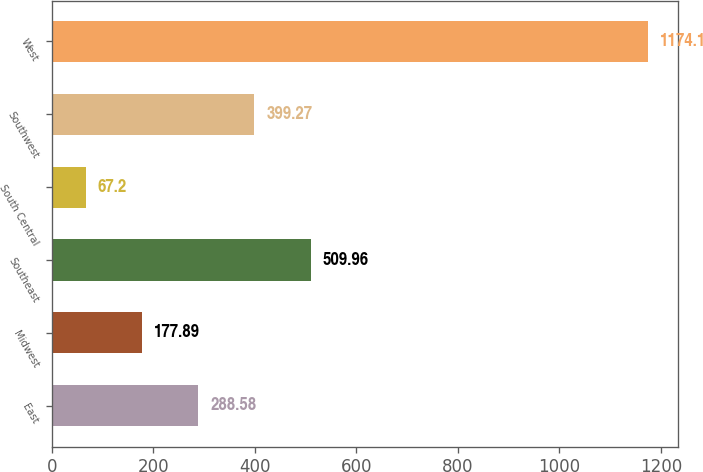Convert chart. <chart><loc_0><loc_0><loc_500><loc_500><bar_chart><fcel>East<fcel>Midwest<fcel>Southeast<fcel>South Central<fcel>Southwest<fcel>West<nl><fcel>288.58<fcel>177.89<fcel>509.96<fcel>67.2<fcel>399.27<fcel>1174.1<nl></chart> 